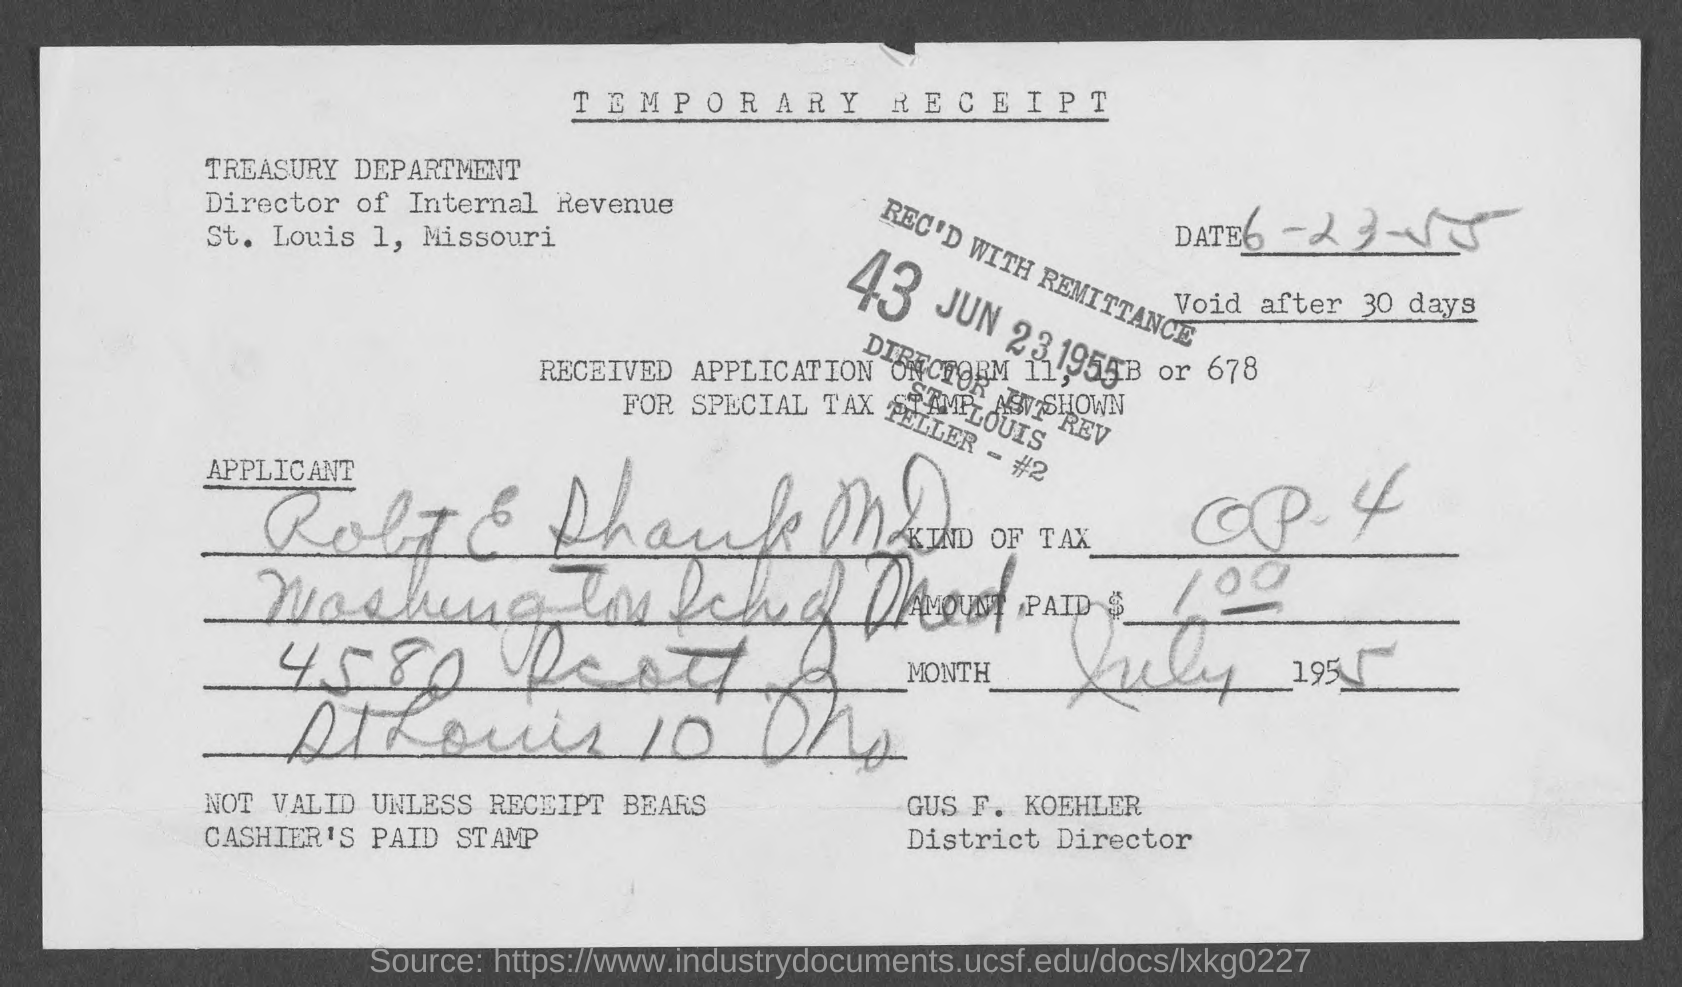What is the name of the receipt?
Keep it short and to the point. Temporary Receipt. Who is the district director ?
Keep it short and to the point. Gus F. Koehler. 